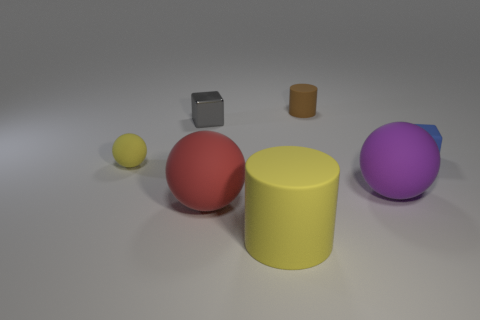Are there any other things that have the same material as the gray block?
Ensure brevity in your answer.  No. Is the size of the red object the same as the yellow object that is in front of the yellow rubber ball?
Your answer should be compact. Yes. How many rubber things are either small cylinders or tiny cubes?
Your answer should be compact. 2. How many red rubber objects are the same shape as the brown object?
Your answer should be very brief. 0. There is a big object that is the same color as the tiny sphere; what is it made of?
Your response must be concise. Rubber. Is the size of the matte cylinder right of the large yellow matte thing the same as the cylinder in front of the small sphere?
Offer a very short reply. No. What is the shape of the tiny matte thing that is right of the purple sphere?
Make the answer very short. Cube. What material is the purple thing that is the same shape as the large red object?
Keep it short and to the point. Rubber. There is a yellow matte object that is on the right side of the red object; is its size the same as the tiny brown cylinder?
Your answer should be very brief. No. How many tiny gray objects are to the left of the tiny rubber cylinder?
Offer a terse response. 1. 